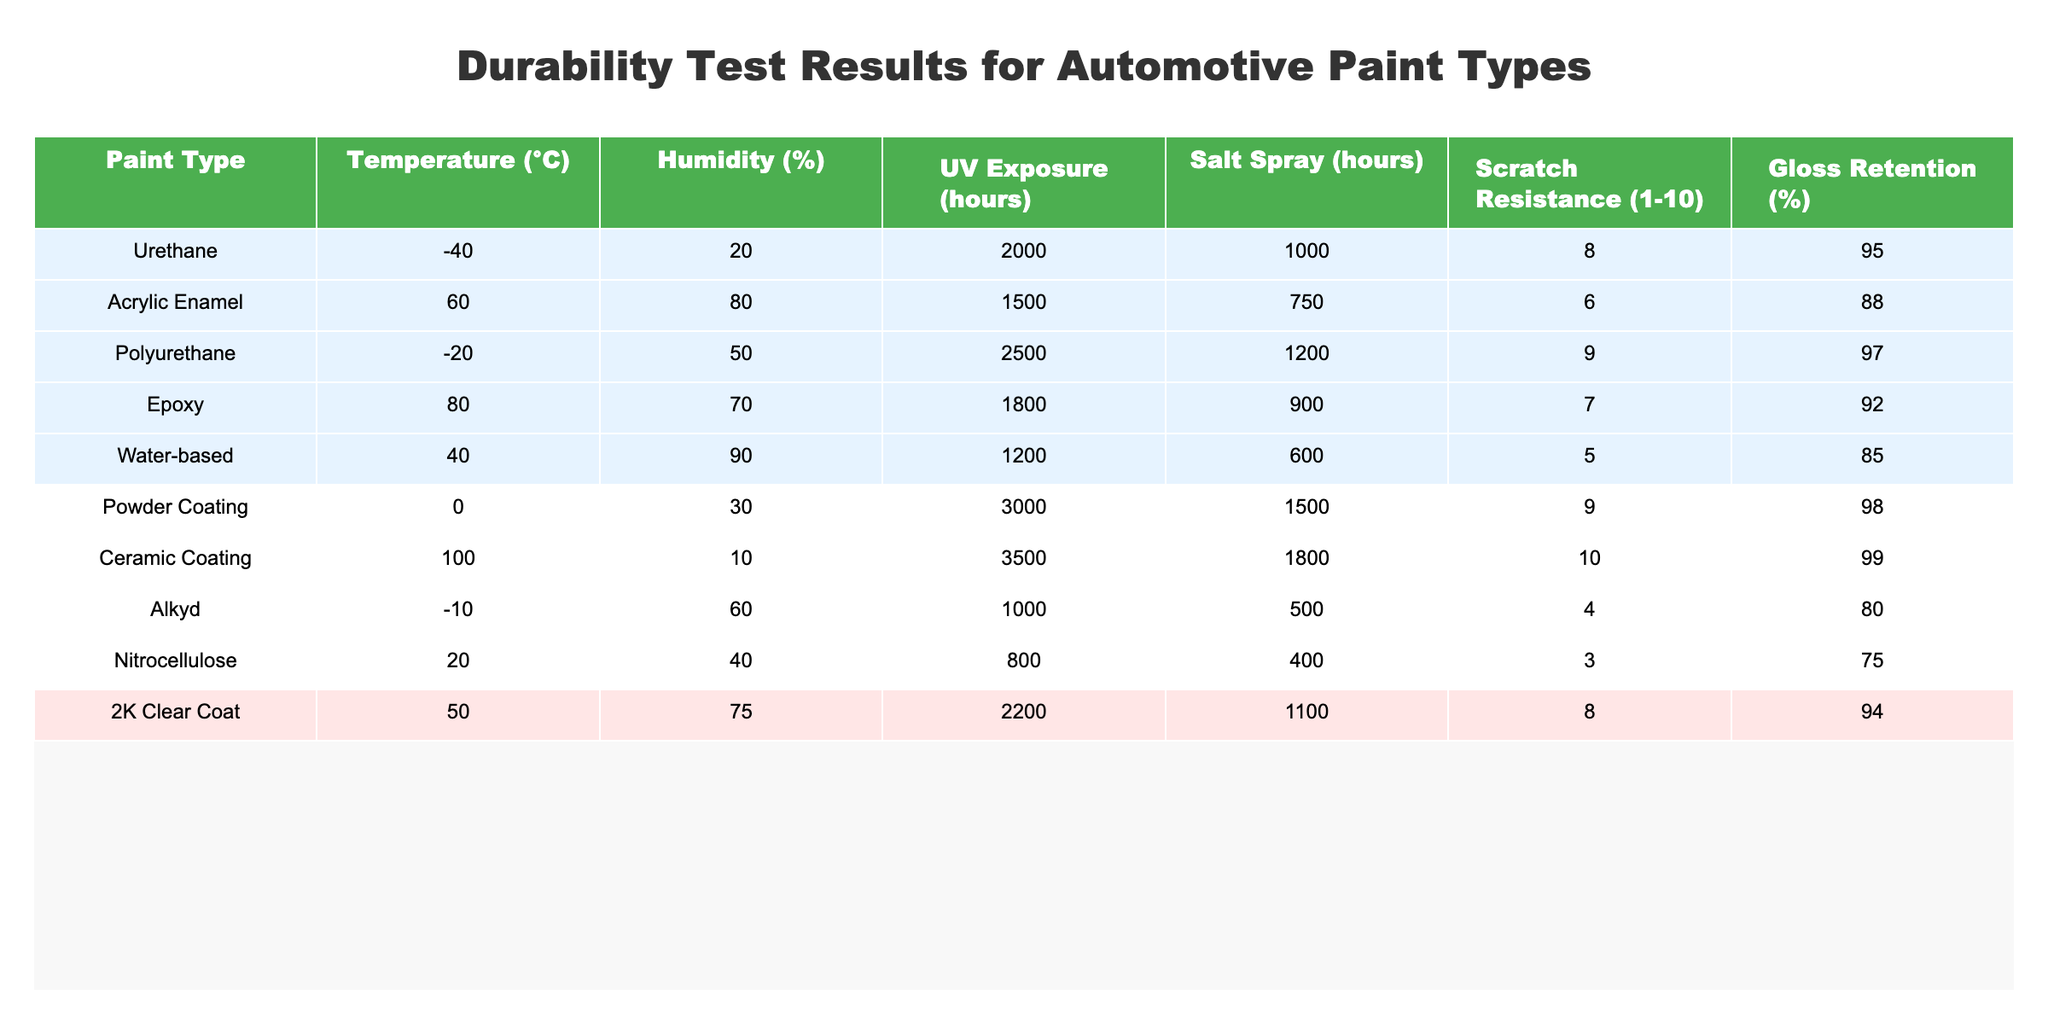What is the scratch resistance rating of the ceramic coating? From the table, we can locate the row for ceramic coating. The scratch resistance rating is explicitly listed in that row, which is 10.
Answer: 10 Which paint type has the maximum gloss retention percentage? By scanning the "Gloss Retention (%)" column for the highest value, we see that ceramic coating ranks at the top with 99%.
Answer: 99% How many hours of UV exposure does the powder coating endure? Looking at the powder coating row under the "UV Exposure (hours)" column, the value is 3000 hours.
Answer: 3000 Which paint type has the lowest scratch resistance? By examining the "Scratch Resistance (1-10)" column, we find that Nitrocellulose has the lowest value of 3, making it the least scratch-resistant option.
Answer: Nitrocellulose What is the average scratch resistance of all paint types listed? To compute the average, we sum all scratch resistance ratings (8 + 6 + 9 + 7 + 5 + 9 + 10 + 4 + 3 + 8) = 69. There are 10 paint types, so we divide 69 by 10, giving us an average of 6.9.
Answer: 6.9 Is the gloss retention of the urethane paint higher than that of the acrylic enamel paint? Comparing the gloss retention values, urethane has 95% while acrylic enamel has 88%. Therefore, urethane is higher.
Answer: Yes Which paint type offers both the highest scratch resistance and the best gloss retention? The table shows that ceramic coating has the highest scratch resistance of 10 and gloss retention of 99%. Therefore, it stands out as the best in both categories.
Answer: Ceramic Coating How much longer can the polyurethane endure in salt spray conditions than the alkyd paint? The values in the "Salt Spray (hours)" column indicate that polyurethane can endure 1200 hours and alkyd can endure only 500 hours. Subtracting these gives us 1200 - 500 = 700 hours longer for polyurethane.
Answer: 700 What are the conditions (temperature and humidity) for the acrylic enamel paint? In the row for acrylic enamel, the temperature is listed as 60°C and the humidity is 80%.
Answer: 60°C, 80% Is there a paint type that can withstand both extremely low temperatures and high temperatures? By reviewing the data, we see that polyurethane withstands -20°C and ceramic coating withstands 100°C. Thus, no single type covers both extremes.
Answer: No 